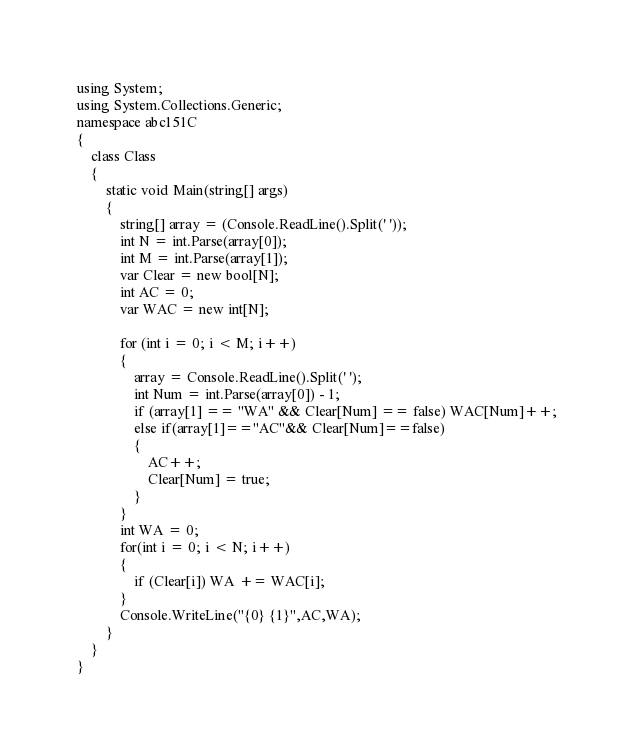<code> <loc_0><loc_0><loc_500><loc_500><_C#_>using System;
using System.Collections.Generic;
namespace abc151C
{
    class Class
    {
        static void Main(string[] args)
        {
            string[] array = (Console.ReadLine().Split(' '));
            int N = int.Parse(array[0]);
            int M = int.Parse(array[1]);
            var Clear = new bool[N];
            int AC = 0;
            var WAC = new int[N];

            for (int i = 0; i < M; i++)
            {
                array = Console.ReadLine().Split(' ');
                int Num = int.Parse(array[0]) - 1;
                if (array[1] == "WA" && Clear[Num] == false) WAC[Num]++;
                else if(array[1]=="AC"&& Clear[Num]==false)
                {
                    AC++;
                    Clear[Num] = true;
                }
            }
            int WA = 0;
            for(int i = 0; i < N; i++)
            {
                if (Clear[i]) WA += WAC[i];
            }
            Console.WriteLine("{0} {1}",AC,WA);
        }
    }
}</code> 